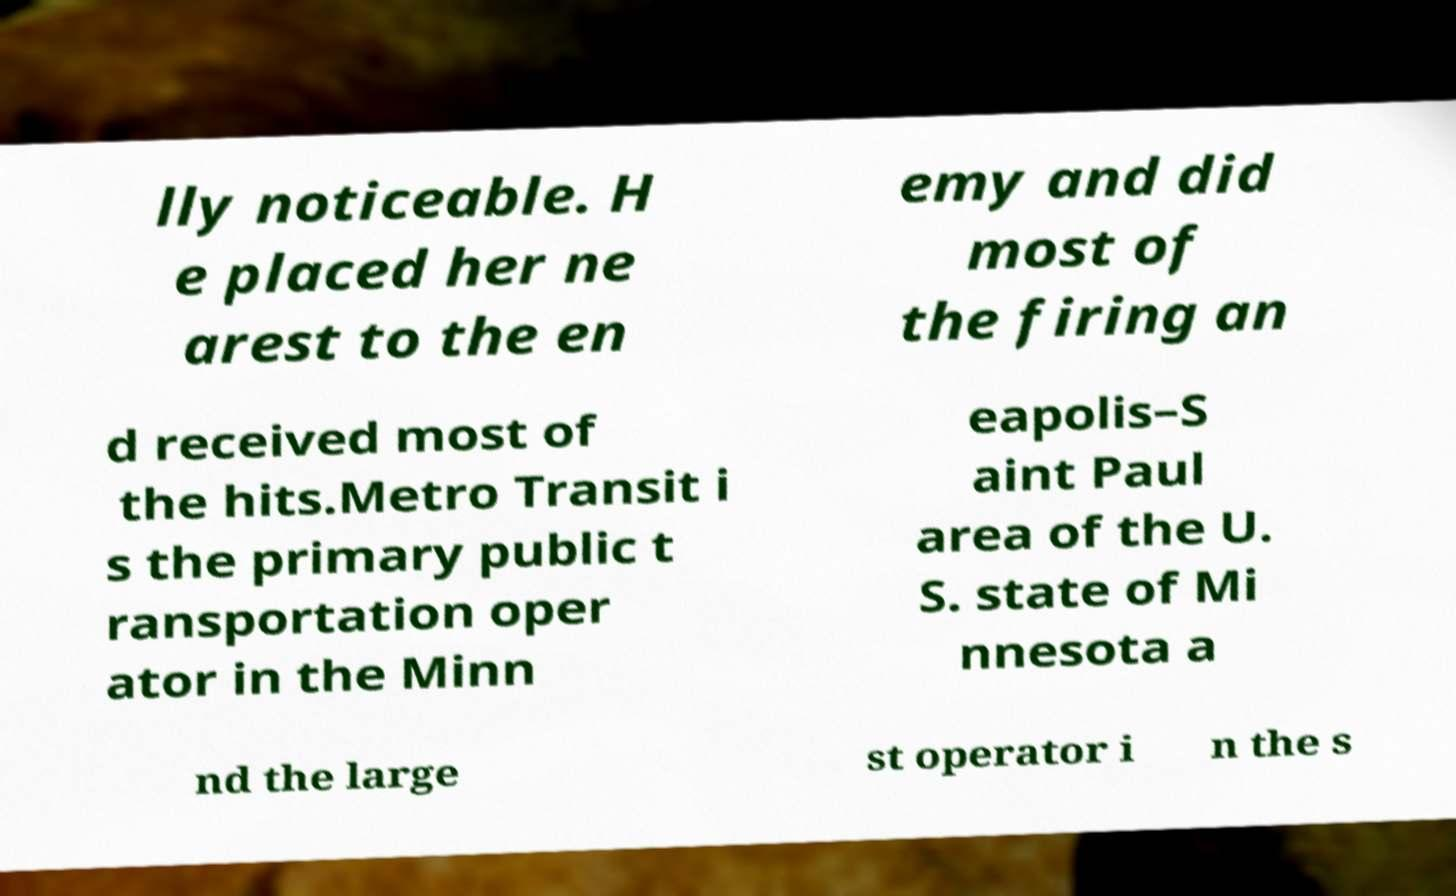Could you assist in decoding the text presented in this image and type it out clearly? lly noticeable. H e placed her ne arest to the en emy and did most of the firing an d received most of the hits.Metro Transit i s the primary public t ransportation oper ator in the Minn eapolis–S aint Paul area of the U. S. state of Mi nnesota a nd the large st operator i n the s 